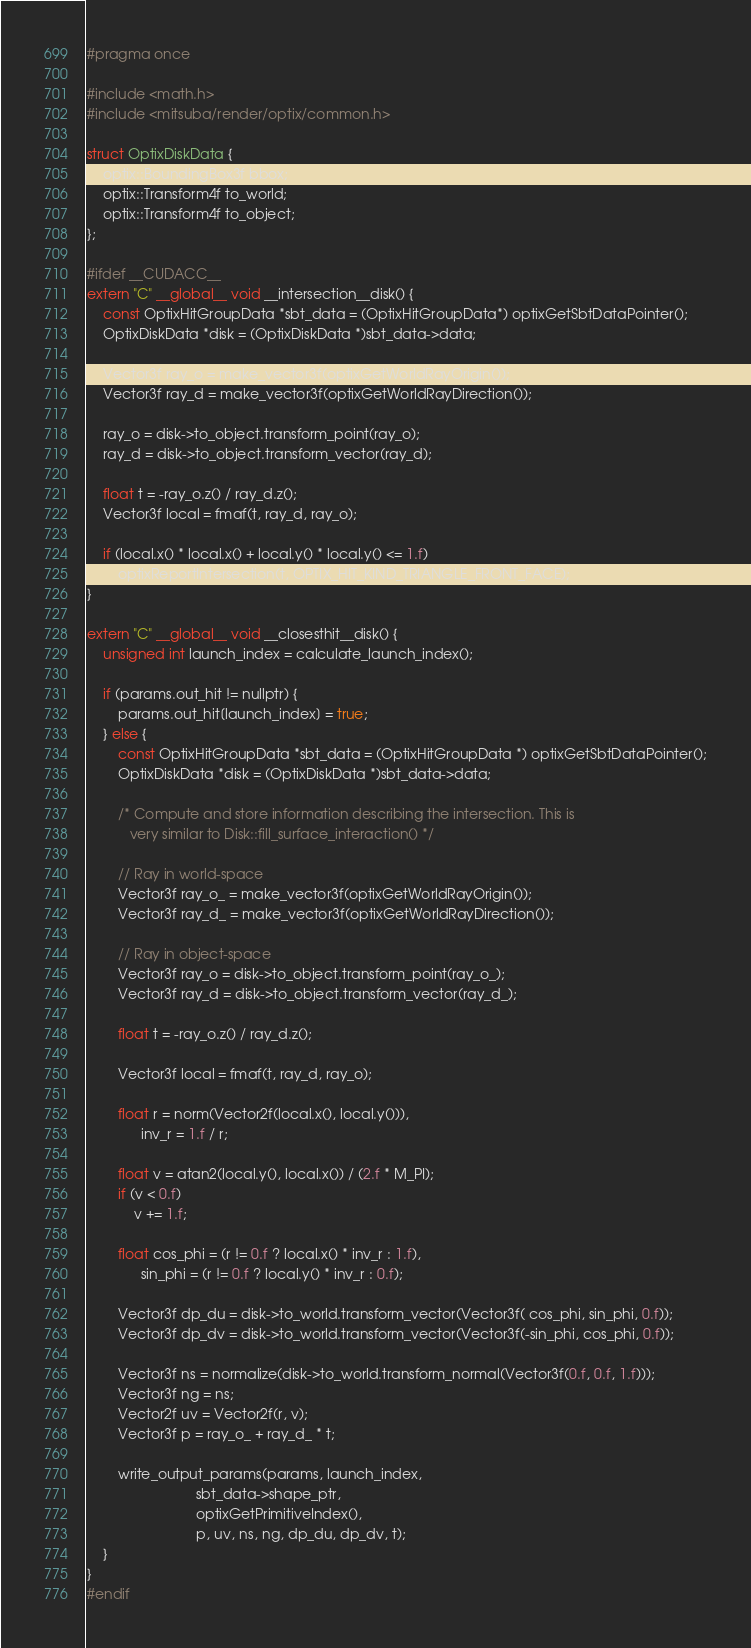<code> <loc_0><loc_0><loc_500><loc_500><_Cuda_>#pragma once

#include <math.h>
#include <mitsuba/render/optix/common.h>

struct OptixDiskData {
    optix::BoundingBox3f bbox;
    optix::Transform4f to_world;
    optix::Transform4f to_object;
};

#ifdef __CUDACC__
extern "C" __global__ void __intersection__disk() {
    const OptixHitGroupData *sbt_data = (OptixHitGroupData*) optixGetSbtDataPointer();
    OptixDiskData *disk = (OptixDiskData *)sbt_data->data;

    Vector3f ray_o = make_vector3f(optixGetWorldRayOrigin());
    Vector3f ray_d = make_vector3f(optixGetWorldRayDirection());

    ray_o = disk->to_object.transform_point(ray_o);
    ray_d = disk->to_object.transform_vector(ray_d);

    float t = -ray_o.z() / ray_d.z();
    Vector3f local = fmaf(t, ray_d, ray_o);

    if (local.x() * local.x() + local.y() * local.y() <= 1.f)
        optixReportIntersection(t, OPTIX_HIT_KIND_TRIANGLE_FRONT_FACE);
}

extern "C" __global__ void __closesthit__disk() {
    unsigned int launch_index = calculate_launch_index();

    if (params.out_hit != nullptr) {
        params.out_hit[launch_index] = true;
    } else {
        const OptixHitGroupData *sbt_data = (OptixHitGroupData *) optixGetSbtDataPointer();
        OptixDiskData *disk = (OptixDiskData *)sbt_data->data;

        /* Compute and store information describing the intersection. This is
           very similar to Disk::fill_surface_interaction() */

        // Ray in world-space
        Vector3f ray_o_ = make_vector3f(optixGetWorldRayOrigin());
        Vector3f ray_d_ = make_vector3f(optixGetWorldRayDirection());

        // Ray in object-space
        Vector3f ray_o = disk->to_object.transform_point(ray_o_);
        Vector3f ray_d = disk->to_object.transform_vector(ray_d_);

        float t = -ray_o.z() / ray_d.z();

        Vector3f local = fmaf(t, ray_d, ray_o);

        float r = norm(Vector2f(local.x(), local.y())),
              inv_r = 1.f / r;

        float v = atan2(local.y(), local.x()) / (2.f * M_PI);
        if (v < 0.f)
            v += 1.f;

        float cos_phi = (r != 0.f ? local.x() * inv_r : 1.f),
              sin_phi = (r != 0.f ? local.y() * inv_r : 0.f);

        Vector3f dp_du = disk->to_world.transform_vector(Vector3f( cos_phi, sin_phi, 0.f));
        Vector3f dp_dv = disk->to_world.transform_vector(Vector3f(-sin_phi, cos_phi, 0.f));

        Vector3f ns = normalize(disk->to_world.transform_normal(Vector3f(0.f, 0.f, 1.f)));
        Vector3f ng = ns;
        Vector2f uv = Vector2f(r, v);
        Vector3f p = ray_o_ + ray_d_ * t;

        write_output_params(params, launch_index,
                            sbt_data->shape_ptr,
                            optixGetPrimitiveIndex(),
                            p, uv, ns, ng, dp_du, dp_dv, t);
    }
}
#endif</code> 